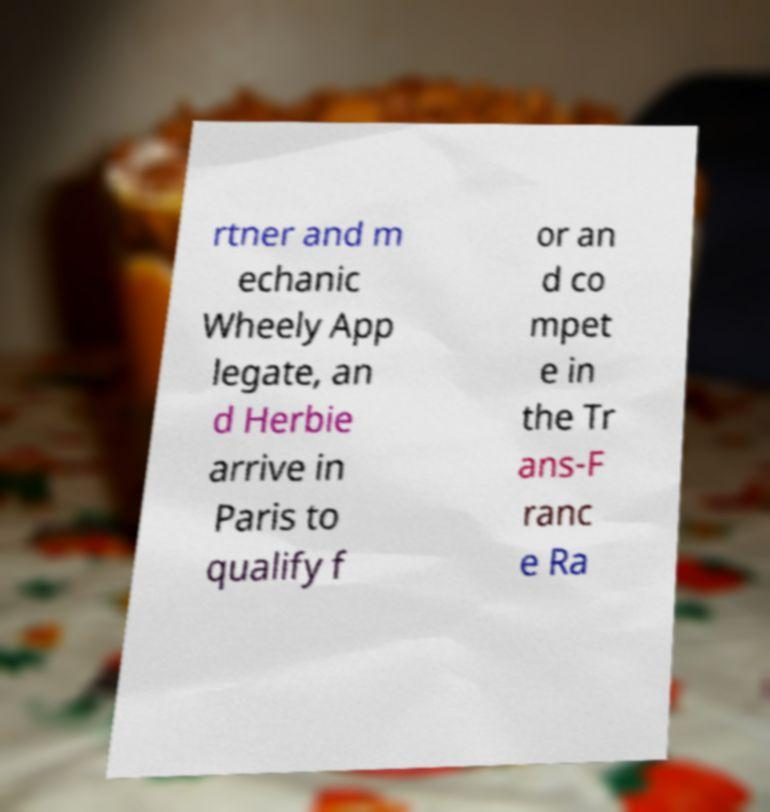Could you assist in decoding the text presented in this image and type it out clearly? rtner and m echanic Wheely App legate, an d Herbie arrive in Paris to qualify f or an d co mpet e in the Tr ans-F ranc e Ra 